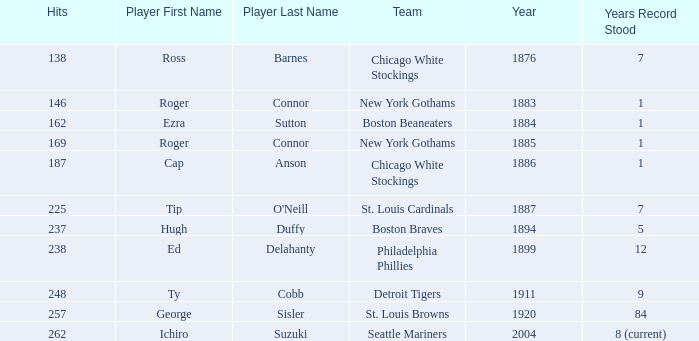Name the least hits for year less than 1920 and player of ed delahanty 238.0. 